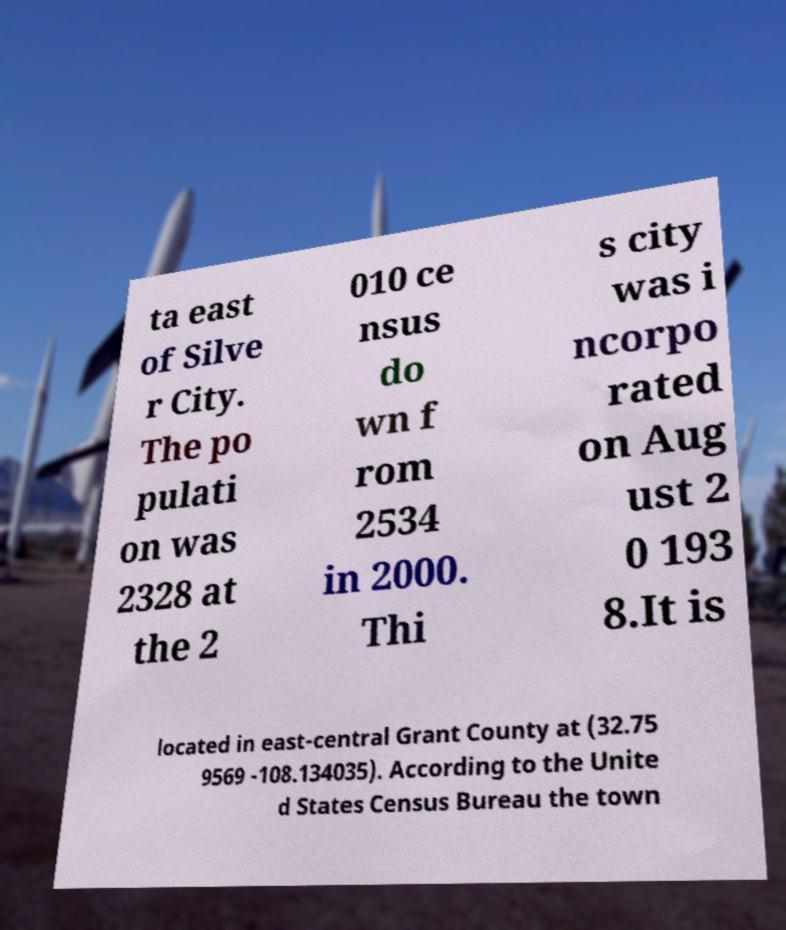There's text embedded in this image that I need extracted. Can you transcribe it verbatim? ta east of Silve r City. The po pulati on was 2328 at the 2 010 ce nsus do wn f rom 2534 in 2000. Thi s city was i ncorpo rated on Aug ust 2 0 193 8.It is located in east-central Grant County at (32.75 9569 -108.134035). According to the Unite d States Census Bureau the town 